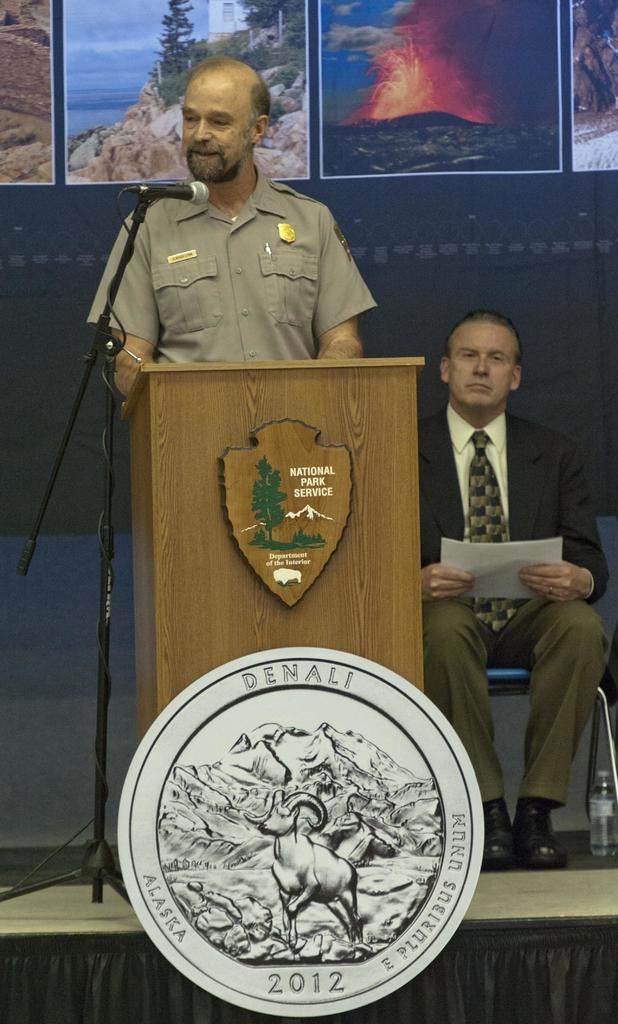<image>
Summarize the visual content of the image. A man at a podium which has National Park Service written on it 